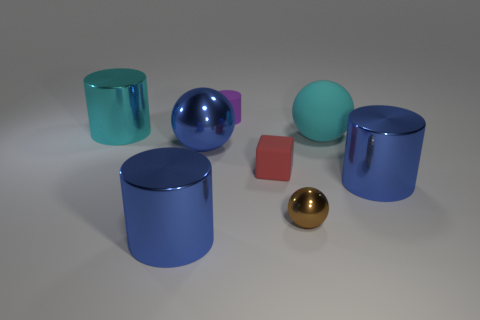Is there a big yellow rubber thing of the same shape as the tiny brown object? While there are several objects of different shapes and colors in the image, none of them is a big yellow rubber object that matches the shape of the tiny brown object. 